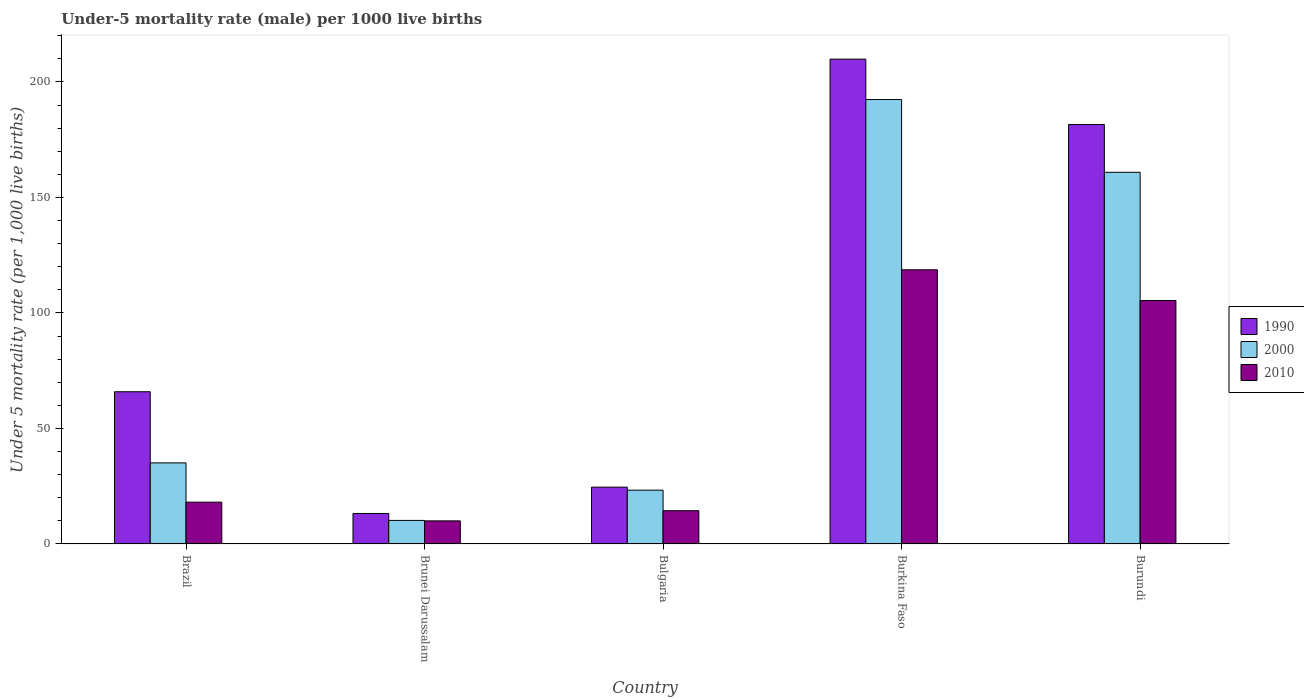How many different coloured bars are there?
Ensure brevity in your answer.  3. How many groups of bars are there?
Make the answer very short. 5. Are the number of bars per tick equal to the number of legend labels?
Offer a terse response. Yes. Are the number of bars on each tick of the X-axis equal?
Offer a very short reply. Yes. What is the label of the 2nd group of bars from the left?
Ensure brevity in your answer.  Brunei Darussalam. What is the under-five mortality rate in 2010 in Burundi?
Provide a succinct answer. 105.4. Across all countries, what is the maximum under-five mortality rate in 2010?
Provide a succinct answer. 118.7. In which country was the under-five mortality rate in 2010 maximum?
Give a very brief answer. Burkina Faso. In which country was the under-five mortality rate in 1990 minimum?
Provide a short and direct response. Brunei Darussalam. What is the total under-five mortality rate in 1990 in the graph?
Give a very brief answer. 495.2. What is the difference between the under-five mortality rate in 2000 in Brunei Darussalam and that in Bulgaria?
Offer a terse response. -13.1. What is the difference between the under-five mortality rate in 2000 in Burundi and the under-five mortality rate in 2010 in Bulgaria?
Make the answer very short. 146.5. What is the average under-five mortality rate in 2010 per country?
Your answer should be very brief. 53.32. What is the difference between the under-five mortality rate of/in 2000 and under-five mortality rate of/in 2010 in Burundi?
Offer a very short reply. 55.5. What is the ratio of the under-five mortality rate in 2010 in Brazil to that in Burundi?
Offer a terse response. 0.17. Is the difference between the under-five mortality rate in 2000 in Bulgaria and Burkina Faso greater than the difference between the under-five mortality rate in 2010 in Bulgaria and Burkina Faso?
Provide a succinct answer. No. What is the difference between the highest and the second highest under-five mortality rate in 2000?
Ensure brevity in your answer.  157.3. What is the difference between the highest and the lowest under-five mortality rate in 1990?
Your answer should be very brief. 196.7. Is it the case that in every country, the sum of the under-five mortality rate in 2010 and under-five mortality rate in 1990 is greater than the under-five mortality rate in 2000?
Provide a short and direct response. Yes. How many bars are there?
Offer a very short reply. 15. Are all the bars in the graph horizontal?
Give a very brief answer. No. Does the graph contain any zero values?
Provide a short and direct response. No. Does the graph contain grids?
Provide a short and direct response. No. Where does the legend appear in the graph?
Provide a short and direct response. Center right. What is the title of the graph?
Make the answer very short. Under-5 mortality rate (male) per 1000 live births. What is the label or title of the Y-axis?
Provide a succinct answer. Under 5 mortality rate (per 1,0 live births). What is the Under 5 mortality rate (per 1,000 live births) in 1990 in Brazil?
Make the answer very short. 65.9. What is the Under 5 mortality rate (per 1,000 live births) in 2000 in Brazil?
Offer a very short reply. 35.1. What is the Under 5 mortality rate (per 1,000 live births) in 2010 in Brazil?
Make the answer very short. 18.1. What is the Under 5 mortality rate (per 1,000 live births) in 1990 in Bulgaria?
Your response must be concise. 24.6. What is the Under 5 mortality rate (per 1,000 live births) in 2000 in Bulgaria?
Your answer should be very brief. 23.3. What is the Under 5 mortality rate (per 1,000 live births) in 2010 in Bulgaria?
Offer a very short reply. 14.4. What is the Under 5 mortality rate (per 1,000 live births) in 1990 in Burkina Faso?
Provide a short and direct response. 209.9. What is the Under 5 mortality rate (per 1,000 live births) of 2000 in Burkina Faso?
Offer a very short reply. 192.4. What is the Under 5 mortality rate (per 1,000 live births) of 2010 in Burkina Faso?
Make the answer very short. 118.7. What is the Under 5 mortality rate (per 1,000 live births) in 1990 in Burundi?
Provide a short and direct response. 181.6. What is the Under 5 mortality rate (per 1,000 live births) of 2000 in Burundi?
Offer a very short reply. 160.9. What is the Under 5 mortality rate (per 1,000 live births) in 2010 in Burundi?
Ensure brevity in your answer.  105.4. Across all countries, what is the maximum Under 5 mortality rate (per 1,000 live births) in 1990?
Provide a succinct answer. 209.9. Across all countries, what is the maximum Under 5 mortality rate (per 1,000 live births) of 2000?
Make the answer very short. 192.4. Across all countries, what is the maximum Under 5 mortality rate (per 1,000 live births) of 2010?
Give a very brief answer. 118.7. Across all countries, what is the minimum Under 5 mortality rate (per 1,000 live births) of 2010?
Your answer should be very brief. 10. What is the total Under 5 mortality rate (per 1,000 live births) in 1990 in the graph?
Ensure brevity in your answer.  495.2. What is the total Under 5 mortality rate (per 1,000 live births) in 2000 in the graph?
Provide a succinct answer. 421.9. What is the total Under 5 mortality rate (per 1,000 live births) in 2010 in the graph?
Your answer should be compact. 266.6. What is the difference between the Under 5 mortality rate (per 1,000 live births) of 1990 in Brazil and that in Brunei Darussalam?
Ensure brevity in your answer.  52.7. What is the difference between the Under 5 mortality rate (per 1,000 live births) of 2000 in Brazil and that in Brunei Darussalam?
Keep it short and to the point. 24.9. What is the difference between the Under 5 mortality rate (per 1,000 live births) in 2010 in Brazil and that in Brunei Darussalam?
Offer a terse response. 8.1. What is the difference between the Under 5 mortality rate (per 1,000 live births) of 1990 in Brazil and that in Bulgaria?
Offer a terse response. 41.3. What is the difference between the Under 5 mortality rate (per 1,000 live births) of 2010 in Brazil and that in Bulgaria?
Keep it short and to the point. 3.7. What is the difference between the Under 5 mortality rate (per 1,000 live births) in 1990 in Brazil and that in Burkina Faso?
Your response must be concise. -144. What is the difference between the Under 5 mortality rate (per 1,000 live births) in 2000 in Brazil and that in Burkina Faso?
Give a very brief answer. -157.3. What is the difference between the Under 5 mortality rate (per 1,000 live births) in 2010 in Brazil and that in Burkina Faso?
Ensure brevity in your answer.  -100.6. What is the difference between the Under 5 mortality rate (per 1,000 live births) of 1990 in Brazil and that in Burundi?
Your answer should be very brief. -115.7. What is the difference between the Under 5 mortality rate (per 1,000 live births) of 2000 in Brazil and that in Burundi?
Provide a short and direct response. -125.8. What is the difference between the Under 5 mortality rate (per 1,000 live births) in 2010 in Brazil and that in Burundi?
Your answer should be very brief. -87.3. What is the difference between the Under 5 mortality rate (per 1,000 live births) in 1990 in Brunei Darussalam and that in Bulgaria?
Give a very brief answer. -11.4. What is the difference between the Under 5 mortality rate (per 1,000 live births) in 2010 in Brunei Darussalam and that in Bulgaria?
Offer a very short reply. -4.4. What is the difference between the Under 5 mortality rate (per 1,000 live births) of 1990 in Brunei Darussalam and that in Burkina Faso?
Ensure brevity in your answer.  -196.7. What is the difference between the Under 5 mortality rate (per 1,000 live births) in 2000 in Brunei Darussalam and that in Burkina Faso?
Offer a very short reply. -182.2. What is the difference between the Under 5 mortality rate (per 1,000 live births) in 2010 in Brunei Darussalam and that in Burkina Faso?
Keep it short and to the point. -108.7. What is the difference between the Under 5 mortality rate (per 1,000 live births) of 1990 in Brunei Darussalam and that in Burundi?
Your answer should be very brief. -168.4. What is the difference between the Under 5 mortality rate (per 1,000 live births) in 2000 in Brunei Darussalam and that in Burundi?
Offer a very short reply. -150.7. What is the difference between the Under 5 mortality rate (per 1,000 live births) in 2010 in Brunei Darussalam and that in Burundi?
Provide a short and direct response. -95.4. What is the difference between the Under 5 mortality rate (per 1,000 live births) of 1990 in Bulgaria and that in Burkina Faso?
Provide a short and direct response. -185.3. What is the difference between the Under 5 mortality rate (per 1,000 live births) of 2000 in Bulgaria and that in Burkina Faso?
Offer a terse response. -169.1. What is the difference between the Under 5 mortality rate (per 1,000 live births) of 2010 in Bulgaria and that in Burkina Faso?
Keep it short and to the point. -104.3. What is the difference between the Under 5 mortality rate (per 1,000 live births) of 1990 in Bulgaria and that in Burundi?
Keep it short and to the point. -157. What is the difference between the Under 5 mortality rate (per 1,000 live births) of 2000 in Bulgaria and that in Burundi?
Your response must be concise. -137.6. What is the difference between the Under 5 mortality rate (per 1,000 live births) in 2010 in Bulgaria and that in Burundi?
Provide a short and direct response. -91. What is the difference between the Under 5 mortality rate (per 1,000 live births) of 1990 in Burkina Faso and that in Burundi?
Ensure brevity in your answer.  28.3. What is the difference between the Under 5 mortality rate (per 1,000 live births) in 2000 in Burkina Faso and that in Burundi?
Your answer should be compact. 31.5. What is the difference between the Under 5 mortality rate (per 1,000 live births) in 1990 in Brazil and the Under 5 mortality rate (per 1,000 live births) in 2000 in Brunei Darussalam?
Your answer should be compact. 55.7. What is the difference between the Under 5 mortality rate (per 1,000 live births) of 1990 in Brazil and the Under 5 mortality rate (per 1,000 live births) of 2010 in Brunei Darussalam?
Offer a very short reply. 55.9. What is the difference between the Under 5 mortality rate (per 1,000 live births) in 2000 in Brazil and the Under 5 mortality rate (per 1,000 live births) in 2010 in Brunei Darussalam?
Keep it short and to the point. 25.1. What is the difference between the Under 5 mortality rate (per 1,000 live births) of 1990 in Brazil and the Under 5 mortality rate (per 1,000 live births) of 2000 in Bulgaria?
Your answer should be very brief. 42.6. What is the difference between the Under 5 mortality rate (per 1,000 live births) in 1990 in Brazil and the Under 5 mortality rate (per 1,000 live births) in 2010 in Bulgaria?
Give a very brief answer. 51.5. What is the difference between the Under 5 mortality rate (per 1,000 live births) in 2000 in Brazil and the Under 5 mortality rate (per 1,000 live births) in 2010 in Bulgaria?
Give a very brief answer. 20.7. What is the difference between the Under 5 mortality rate (per 1,000 live births) in 1990 in Brazil and the Under 5 mortality rate (per 1,000 live births) in 2000 in Burkina Faso?
Ensure brevity in your answer.  -126.5. What is the difference between the Under 5 mortality rate (per 1,000 live births) of 1990 in Brazil and the Under 5 mortality rate (per 1,000 live births) of 2010 in Burkina Faso?
Offer a very short reply. -52.8. What is the difference between the Under 5 mortality rate (per 1,000 live births) in 2000 in Brazil and the Under 5 mortality rate (per 1,000 live births) in 2010 in Burkina Faso?
Offer a very short reply. -83.6. What is the difference between the Under 5 mortality rate (per 1,000 live births) of 1990 in Brazil and the Under 5 mortality rate (per 1,000 live births) of 2000 in Burundi?
Ensure brevity in your answer.  -95. What is the difference between the Under 5 mortality rate (per 1,000 live births) in 1990 in Brazil and the Under 5 mortality rate (per 1,000 live births) in 2010 in Burundi?
Make the answer very short. -39.5. What is the difference between the Under 5 mortality rate (per 1,000 live births) of 2000 in Brazil and the Under 5 mortality rate (per 1,000 live births) of 2010 in Burundi?
Make the answer very short. -70.3. What is the difference between the Under 5 mortality rate (per 1,000 live births) of 1990 in Brunei Darussalam and the Under 5 mortality rate (per 1,000 live births) of 2000 in Bulgaria?
Keep it short and to the point. -10.1. What is the difference between the Under 5 mortality rate (per 1,000 live births) in 2000 in Brunei Darussalam and the Under 5 mortality rate (per 1,000 live births) in 2010 in Bulgaria?
Give a very brief answer. -4.2. What is the difference between the Under 5 mortality rate (per 1,000 live births) of 1990 in Brunei Darussalam and the Under 5 mortality rate (per 1,000 live births) of 2000 in Burkina Faso?
Make the answer very short. -179.2. What is the difference between the Under 5 mortality rate (per 1,000 live births) in 1990 in Brunei Darussalam and the Under 5 mortality rate (per 1,000 live births) in 2010 in Burkina Faso?
Provide a succinct answer. -105.5. What is the difference between the Under 5 mortality rate (per 1,000 live births) in 2000 in Brunei Darussalam and the Under 5 mortality rate (per 1,000 live births) in 2010 in Burkina Faso?
Provide a succinct answer. -108.5. What is the difference between the Under 5 mortality rate (per 1,000 live births) of 1990 in Brunei Darussalam and the Under 5 mortality rate (per 1,000 live births) of 2000 in Burundi?
Provide a succinct answer. -147.7. What is the difference between the Under 5 mortality rate (per 1,000 live births) in 1990 in Brunei Darussalam and the Under 5 mortality rate (per 1,000 live births) in 2010 in Burundi?
Make the answer very short. -92.2. What is the difference between the Under 5 mortality rate (per 1,000 live births) in 2000 in Brunei Darussalam and the Under 5 mortality rate (per 1,000 live births) in 2010 in Burundi?
Provide a short and direct response. -95.2. What is the difference between the Under 5 mortality rate (per 1,000 live births) in 1990 in Bulgaria and the Under 5 mortality rate (per 1,000 live births) in 2000 in Burkina Faso?
Provide a succinct answer. -167.8. What is the difference between the Under 5 mortality rate (per 1,000 live births) in 1990 in Bulgaria and the Under 5 mortality rate (per 1,000 live births) in 2010 in Burkina Faso?
Offer a terse response. -94.1. What is the difference between the Under 5 mortality rate (per 1,000 live births) in 2000 in Bulgaria and the Under 5 mortality rate (per 1,000 live births) in 2010 in Burkina Faso?
Offer a terse response. -95.4. What is the difference between the Under 5 mortality rate (per 1,000 live births) in 1990 in Bulgaria and the Under 5 mortality rate (per 1,000 live births) in 2000 in Burundi?
Your response must be concise. -136.3. What is the difference between the Under 5 mortality rate (per 1,000 live births) of 1990 in Bulgaria and the Under 5 mortality rate (per 1,000 live births) of 2010 in Burundi?
Ensure brevity in your answer.  -80.8. What is the difference between the Under 5 mortality rate (per 1,000 live births) of 2000 in Bulgaria and the Under 5 mortality rate (per 1,000 live births) of 2010 in Burundi?
Make the answer very short. -82.1. What is the difference between the Under 5 mortality rate (per 1,000 live births) of 1990 in Burkina Faso and the Under 5 mortality rate (per 1,000 live births) of 2010 in Burundi?
Give a very brief answer. 104.5. What is the average Under 5 mortality rate (per 1,000 live births) in 1990 per country?
Your response must be concise. 99.04. What is the average Under 5 mortality rate (per 1,000 live births) in 2000 per country?
Give a very brief answer. 84.38. What is the average Under 5 mortality rate (per 1,000 live births) in 2010 per country?
Give a very brief answer. 53.32. What is the difference between the Under 5 mortality rate (per 1,000 live births) of 1990 and Under 5 mortality rate (per 1,000 live births) of 2000 in Brazil?
Provide a succinct answer. 30.8. What is the difference between the Under 5 mortality rate (per 1,000 live births) of 1990 and Under 5 mortality rate (per 1,000 live births) of 2010 in Brazil?
Give a very brief answer. 47.8. What is the difference between the Under 5 mortality rate (per 1,000 live births) in 2000 and Under 5 mortality rate (per 1,000 live births) in 2010 in Brazil?
Make the answer very short. 17. What is the difference between the Under 5 mortality rate (per 1,000 live births) in 1990 and Under 5 mortality rate (per 1,000 live births) in 2000 in Brunei Darussalam?
Give a very brief answer. 3. What is the difference between the Under 5 mortality rate (per 1,000 live births) in 1990 and Under 5 mortality rate (per 1,000 live births) in 2010 in Bulgaria?
Offer a terse response. 10.2. What is the difference between the Under 5 mortality rate (per 1,000 live births) in 2000 and Under 5 mortality rate (per 1,000 live births) in 2010 in Bulgaria?
Keep it short and to the point. 8.9. What is the difference between the Under 5 mortality rate (per 1,000 live births) of 1990 and Under 5 mortality rate (per 1,000 live births) of 2010 in Burkina Faso?
Give a very brief answer. 91.2. What is the difference between the Under 5 mortality rate (per 1,000 live births) of 2000 and Under 5 mortality rate (per 1,000 live births) of 2010 in Burkina Faso?
Offer a very short reply. 73.7. What is the difference between the Under 5 mortality rate (per 1,000 live births) of 1990 and Under 5 mortality rate (per 1,000 live births) of 2000 in Burundi?
Your answer should be compact. 20.7. What is the difference between the Under 5 mortality rate (per 1,000 live births) of 1990 and Under 5 mortality rate (per 1,000 live births) of 2010 in Burundi?
Keep it short and to the point. 76.2. What is the difference between the Under 5 mortality rate (per 1,000 live births) in 2000 and Under 5 mortality rate (per 1,000 live births) in 2010 in Burundi?
Keep it short and to the point. 55.5. What is the ratio of the Under 5 mortality rate (per 1,000 live births) of 1990 in Brazil to that in Brunei Darussalam?
Provide a succinct answer. 4.99. What is the ratio of the Under 5 mortality rate (per 1,000 live births) of 2000 in Brazil to that in Brunei Darussalam?
Keep it short and to the point. 3.44. What is the ratio of the Under 5 mortality rate (per 1,000 live births) of 2010 in Brazil to that in Brunei Darussalam?
Make the answer very short. 1.81. What is the ratio of the Under 5 mortality rate (per 1,000 live births) of 1990 in Brazil to that in Bulgaria?
Offer a very short reply. 2.68. What is the ratio of the Under 5 mortality rate (per 1,000 live births) in 2000 in Brazil to that in Bulgaria?
Offer a very short reply. 1.51. What is the ratio of the Under 5 mortality rate (per 1,000 live births) in 2010 in Brazil to that in Bulgaria?
Your answer should be very brief. 1.26. What is the ratio of the Under 5 mortality rate (per 1,000 live births) of 1990 in Brazil to that in Burkina Faso?
Provide a short and direct response. 0.31. What is the ratio of the Under 5 mortality rate (per 1,000 live births) in 2000 in Brazil to that in Burkina Faso?
Offer a terse response. 0.18. What is the ratio of the Under 5 mortality rate (per 1,000 live births) in 2010 in Brazil to that in Burkina Faso?
Your answer should be compact. 0.15. What is the ratio of the Under 5 mortality rate (per 1,000 live births) of 1990 in Brazil to that in Burundi?
Give a very brief answer. 0.36. What is the ratio of the Under 5 mortality rate (per 1,000 live births) in 2000 in Brazil to that in Burundi?
Provide a short and direct response. 0.22. What is the ratio of the Under 5 mortality rate (per 1,000 live births) in 2010 in Brazil to that in Burundi?
Your answer should be very brief. 0.17. What is the ratio of the Under 5 mortality rate (per 1,000 live births) in 1990 in Brunei Darussalam to that in Bulgaria?
Your answer should be very brief. 0.54. What is the ratio of the Under 5 mortality rate (per 1,000 live births) in 2000 in Brunei Darussalam to that in Bulgaria?
Your answer should be compact. 0.44. What is the ratio of the Under 5 mortality rate (per 1,000 live births) of 2010 in Brunei Darussalam to that in Bulgaria?
Offer a terse response. 0.69. What is the ratio of the Under 5 mortality rate (per 1,000 live births) of 1990 in Brunei Darussalam to that in Burkina Faso?
Your response must be concise. 0.06. What is the ratio of the Under 5 mortality rate (per 1,000 live births) in 2000 in Brunei Darussalam to that in Burkina Faso?
Offer a very short reply. 0.05. What is the ratio of the Under 5 mortality rate (per 1,000 live births) in 2010 in Brunei Darussalam to that in Burkina Faso?
Your answer should be compact. 0.08. What is the ratio of the Under 5 mortality rate (per 1,000 live births) of 1990 in Brunei Darussalam to that in Burundi?
Offer a terse response. 0.07. What is the ratio of the Under 5 mortality rate (per 1,000 live births) of 2000 in Brunei Darussalam to that in Burundi?
Your answer should be very brief. 0.06. What is the ratio of the Under 5 mortality rate (per 1,000 live births) of 2010 in Brunei Darussalam to that in Burundi?
Provide a succinct answer. 0.09. What is the ratio of the Under 5 mortality rate (per 1,000 live births) of 1990 in Bulgaria to that in Burkina Faso?
Offer a very short reply. 0.12. What is the ratio of the Under 5 mortality rate (per 1,000 live births) in 2000 in Bulgaria to that in Burkina Faso?
Your response must be concise. 0.12. What is the ratio of the Under 5 mortality rate (per 1,000 live births) in 2010 in Bulgaria to that in Burkina Faso?
Make the answer very short. 0.12. What is the ratio of the Under 5 mortality rate (per 1,000 live births) in 1990 in Bulgaria to that in Burundi?
Provide a short and direct response. 0.14. What is the ratio of the Under 5 mortality rate (per 1,000 live births) of 2000 in Bulgaria to that in Burundi?
Make the answer very short. 0.14. What is the ratio of the Under 5 mortality rate (per 1,000 live births) in 2010 in Bulgaria to that in Burundi?
Give a very brief answer. 0.14. What is the ratio of the Under 5 mortality rate (per 1,000 live births) of 1990 in Burkina Faso to that in Burundi?
Keep it short and to the point. 1.16. What is the ratio of the Under 5 mortality rate (per 1,000 live births) of 2000 in Burkina Faso to that in Burundi?
Your answer should be very brief. 1.2. What is the ratio of the Under 5 mortality rate (per 1,000 live births) of 2010 in Burkina Faso to that in Burundi?
Your response must be concise. 1.13. What is the difference between the highest and the second highest Under 5 mortality rate (per 1,000 live births) of 1990?
Your answer should be compact. 28.3. What is the difference between the highest and the second highest Under 5 mortality rate (per 1,000 live births) of 2000?
Give a very brief answer. 31.5. What is the difference between the highest and the second highest Under 5 mortality rate (per 1,000 live births) of 2010?
Provide a short and direct response. 13.3. What is the difference between the highest and the lowest Under 5 mortality rate (per 1,000 live births) in 1990?
Keep it short and to the point. 196.7. What is the difference between the highest and the lowest Under 5 mortality rate (per 1,000 live births) of 2000?
Offer a very short reply. 182.2. What is the difference between the highest and the lowest Under 5 mortality rate (per 1,000 live births) in 2010?
Provide a succinct answer. 108.7. 